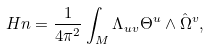<formula> <loc_0><loc_0><loc_500><loc_500>H n = { \frac { 1 } { 4 \pi ^ { 2 } } } \int _ { M } \Lambda _ { u v } \Theta ^ { u } \wedge \hat { \Omega } ^ { v } ,</formula> 